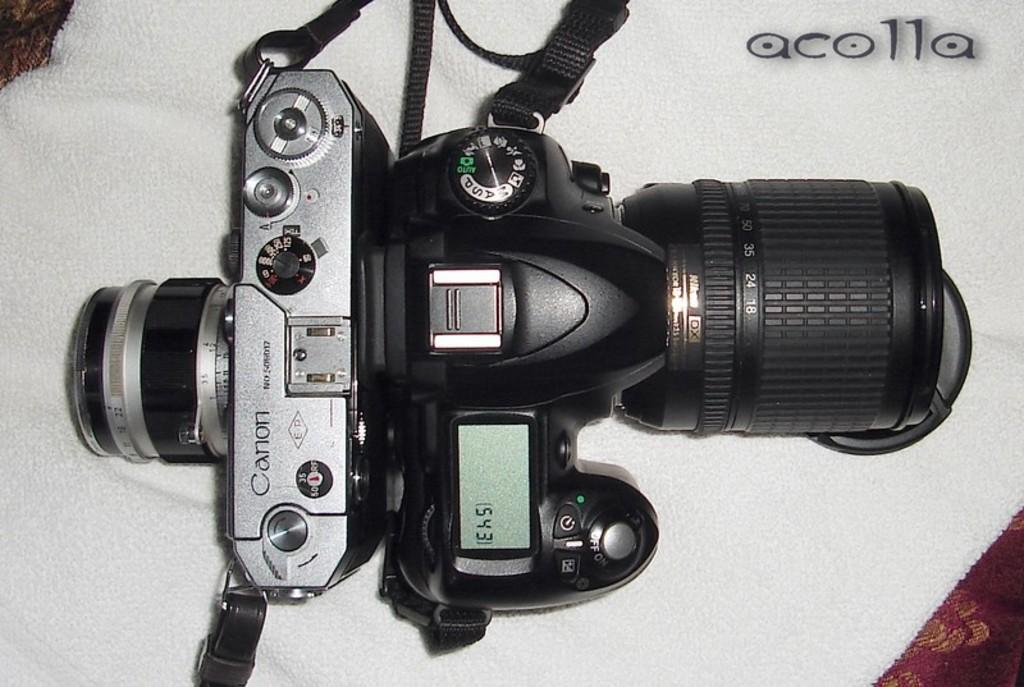What is the main object in the image? There is a camera in the image. Where is the camera positioned? The camera is on a platform. What else can be seen in the image besides the camera? There is text visible in the top right of the image. What type of pain is the insect experiencing in the image? There is no insect present in the image, and therefore no such pain can be observed. 